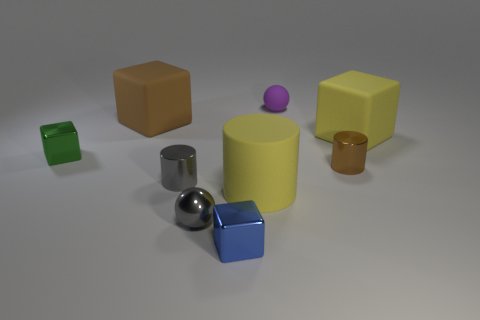The cylinder that is the same color as the shiny sphere is what size?
Your answer should be very brief. Small. How many other things are there of the same color as the tiny metal ball?
Give a very brief answer. 1. Are the blue cube left of the yellow matte cylinder and the yellow object that is to the right of the yellow cylinder made of the same material?
Keep it short and to the point. No. Is there a gray shiny thing that has the same size as the gray ball?
Offer a very short reply. Yes. What is the size of the cylinder that is right of the large yellow matte object left of the purple rubber sphere?
Offer a terse response. Small. What number of tiny cubes have the same color as the tiny matte object?
Your response must be concise. 0. The gray metallic object that is behind the big rubber object in front of the small gray metallic cylinder is what shape?
Ensure brevity in your answer.  Cylinder. How many brown cubes have the same material as the tiny gray cylinder?
Ensure brevity in your answer.  0. What is the large yellow thing that is on the left side of the purple rubber thing made of?
Provide a succinct answer. Rubber. What is the shape of the yellow object that is left of the sphere behind the tiny shiny cube left of the small blue metal block?
Provide a short and direct response. Cylinder. 